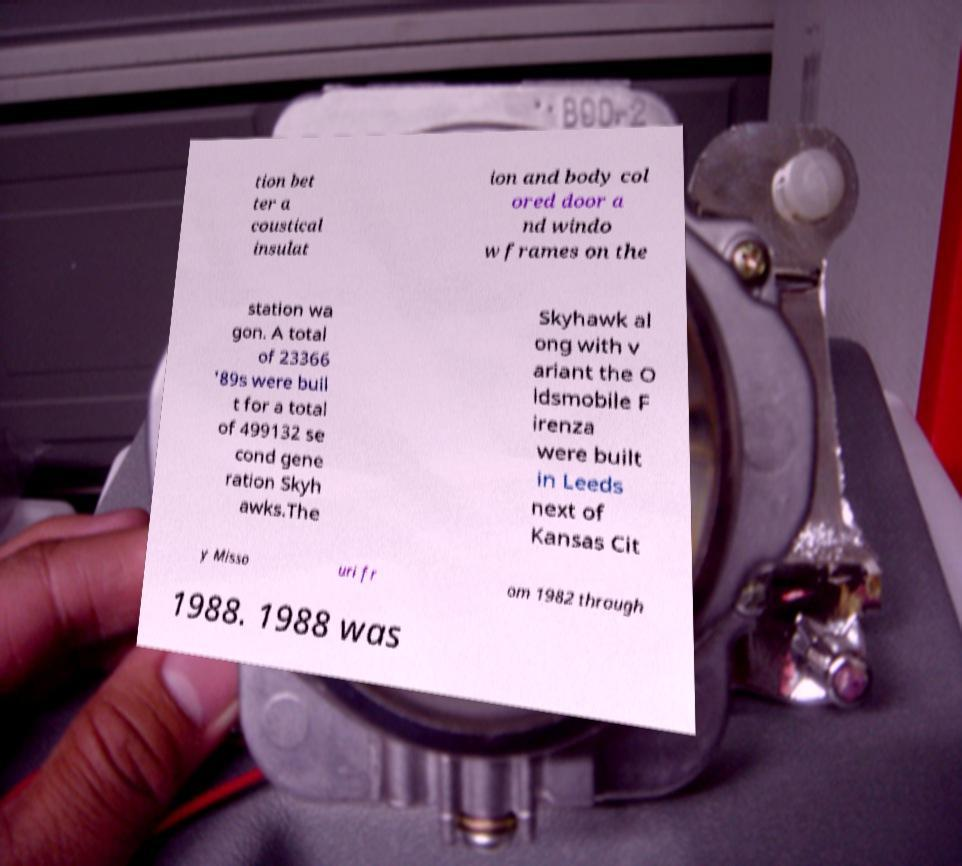There's text embedded in this image that I need extracted. Can you transcribe it verbatim? tion bet ter a coustical insulat ion and body col ored door a nd windo w frames on the station wa gon. A total of 23366 '89s were buil t for a total of 499132 se cond gene ration Skyh awks.The Skyhawk al ong with v ariant the O ldsmobile F irenza were built in Leeds next of Kansas Cit y Misso uri fr om 1982 through 1988. 1988 was 